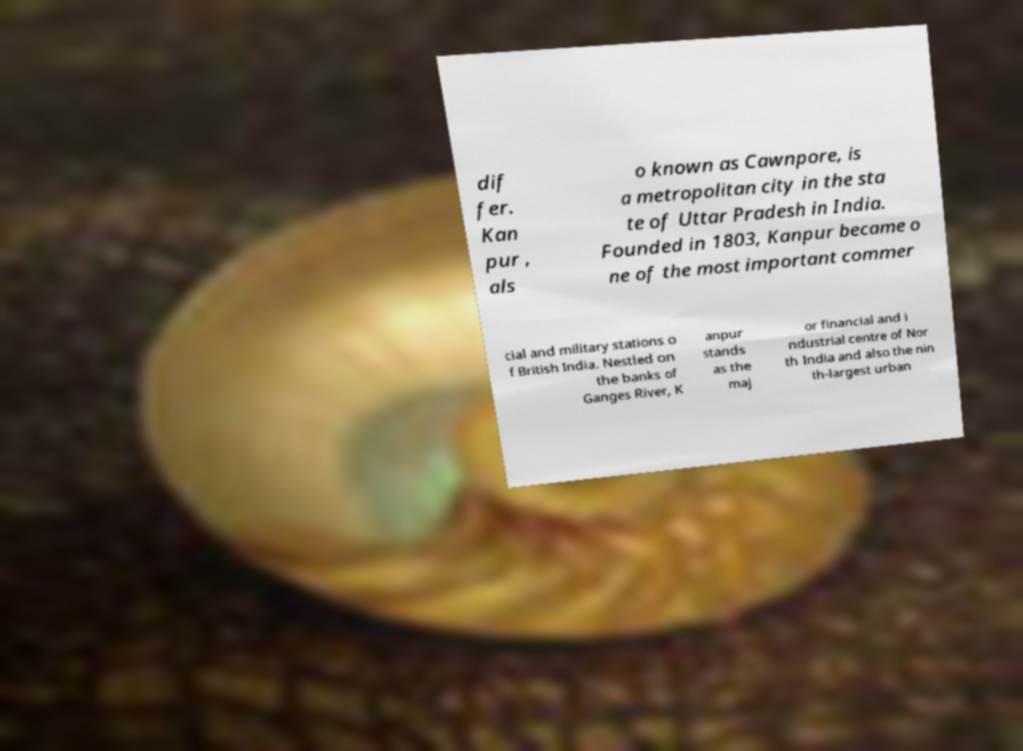Could you extract and type out the text from this image? dif fer. Kan pur , als o known as Cawnpore, is a metropolitan city in the sta te of Uttar Pradesh in India. Founded in 1803, Kanpur became o ne of the most important commer cial and military stations o f British India. Nestled on the banks of Ganges River, K anpur stands as the maj or financial and i ndustrial centre of Nor th India and also the nin th-largest urban 